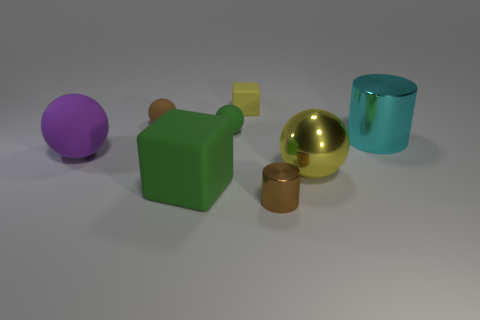Add 1 matte objects. How many objects exist? 9 Subtract all blocks. How many objects are left? 6 Add 1 yellow rubber blocks. How many yellow rubber blocks exist? 2 Subtract 1 green cubes. How many objects are left? 7 Subtract all large shiny cylinders. Subtract all large rubber things. How many objects are left? 5 Add 5 cylinders. How many cylinders are left? 7 